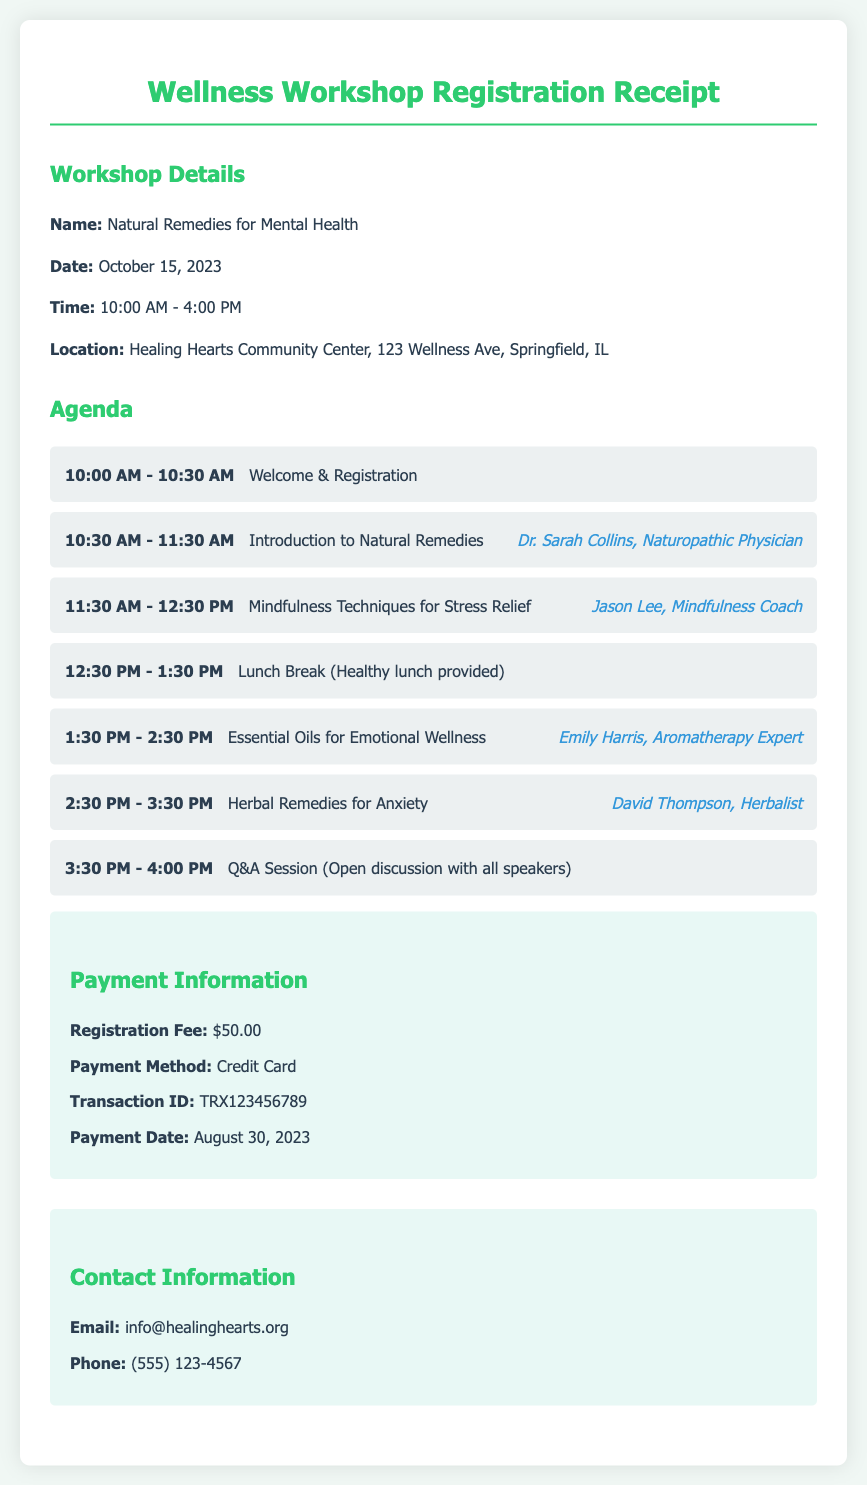What is the name of the workshop? The name of the workshop is mentioned in the workshop details section.
Answer: Natural Remedies for Mental Health What is the date of the workshop? The date of the workshop is provided alongside the workshop details.
Answer: October 15, 2023 Who is the speaker for the session on Essential Oils? This information is found in the agenda section where each speaker's name is provided next to their session.
Answer: Emily Harris What is the registration fee? The registration fee is listed under the payment information section of the document.
Answer: $50.00 What time does the workshop start? The starting time is indicated in the workshop details.
Answer: 10:00 AM What is the transaction ID of the payment? The transaction ID can be found in the payment information section of the document.
Answer: TRX123456789 What activity is scheduled for 12:30 PM? This activity is detailed in the agenda with timings.
Answer: Lunch Break (Healthy lunch provided) Who can I contact for more information? The contact information section includes details for getting in touch.
Answer: info@healinghearts.org What is the location of the workshop? The location is provided in the workshop details section.
Answer: Healing Hearts Community Center, 123 Wellness Ave, Springfield, IL 